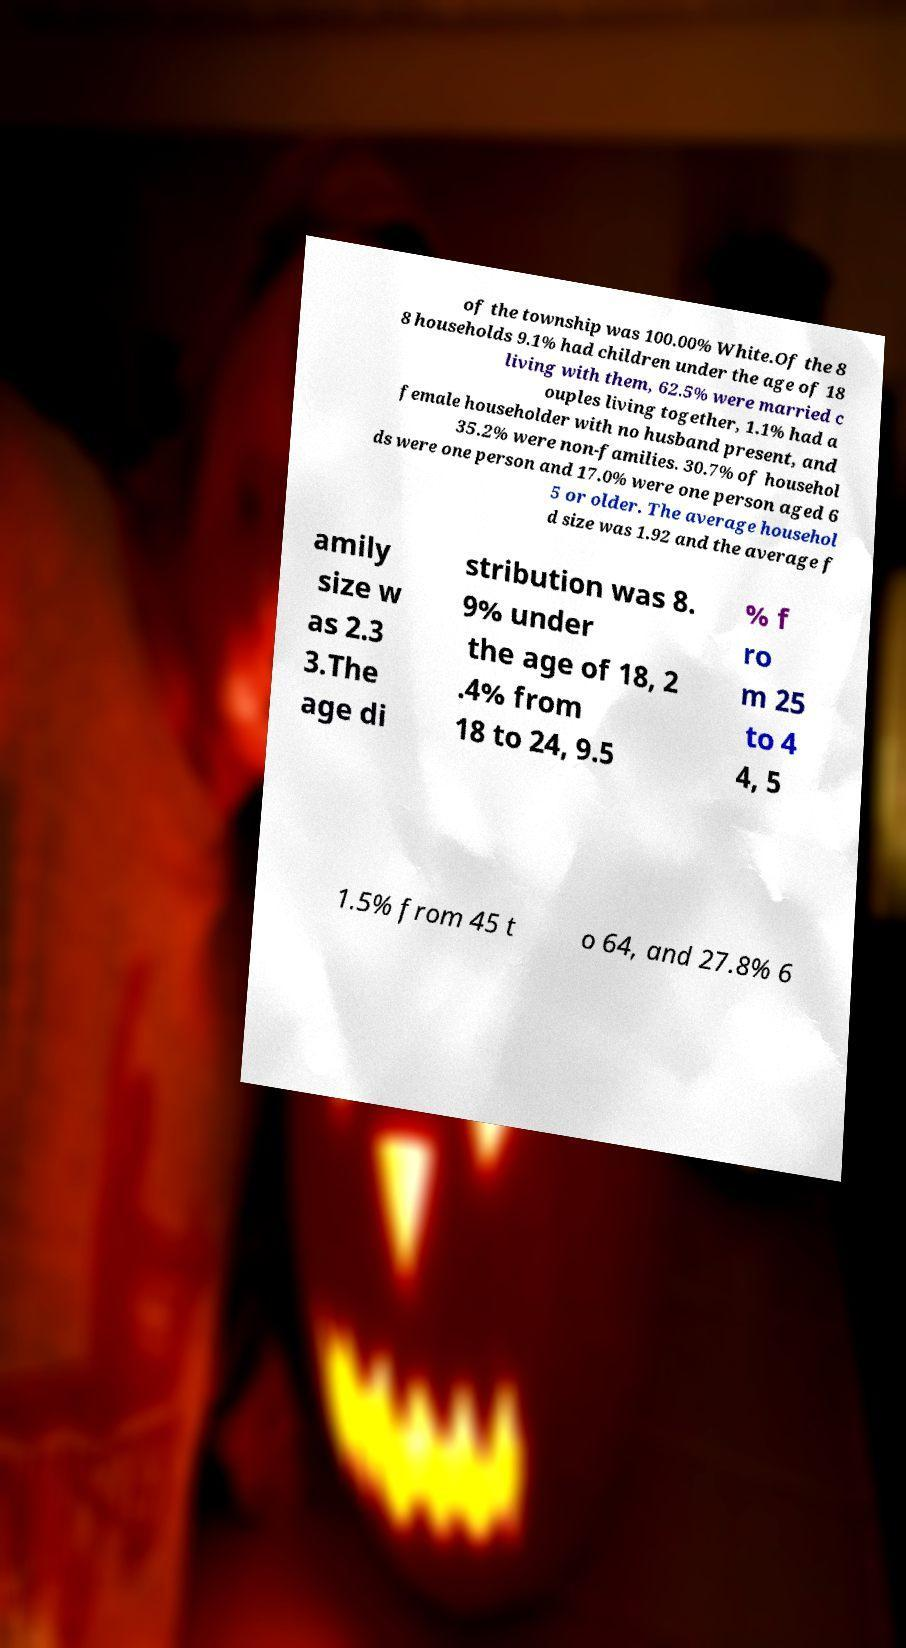Could you extract and type out the text from this image? of the township was 100.00% White.Of the 8 8 households 9.1% had children under the age of 18 living with them, 62.5% were married c ouples living together, 1.1% had a female householder with no husband present, and 35.2% were non-families. 30.7% of househol ds were one person and 17.0% were one person aged 6 5 or older. The average househol d size was 1.92 and the average f amily size w as 2.3 3.The age di stribution was 8. 9% under the age of 18, 2 .4% from 18 to 24, 9.5 % f ro m 25 to 4 4, 5 1.5% from 45 t o 64, and 27.8% 6 